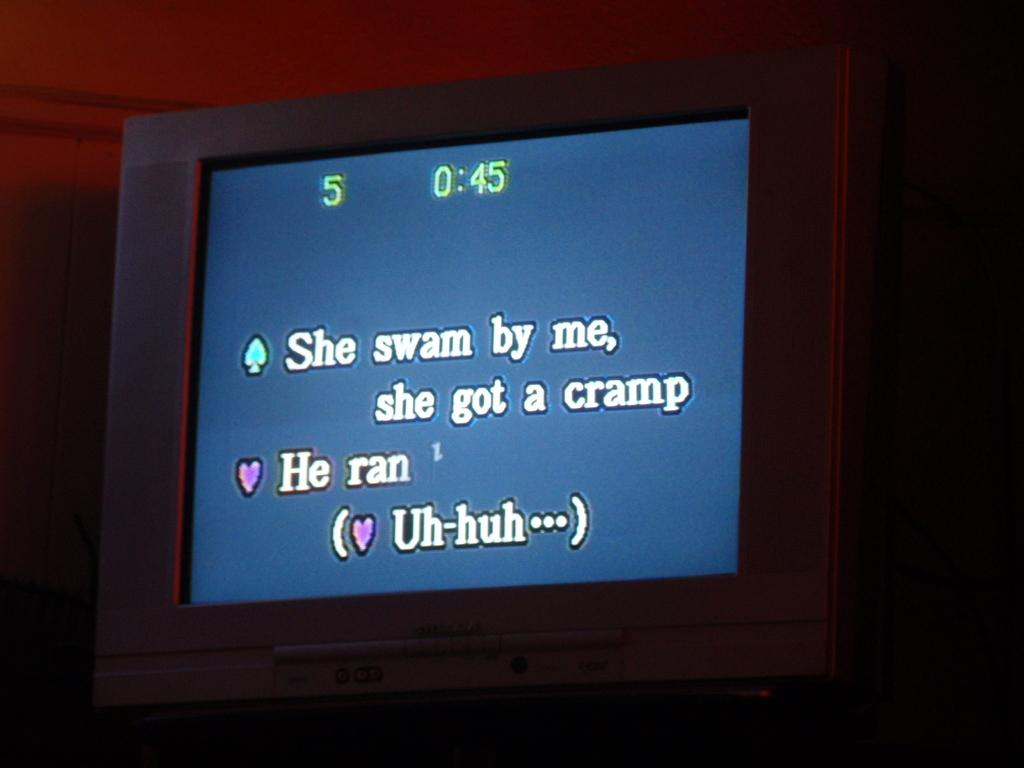<image>
Describe the image concisely. some words that say she swam by me on it 